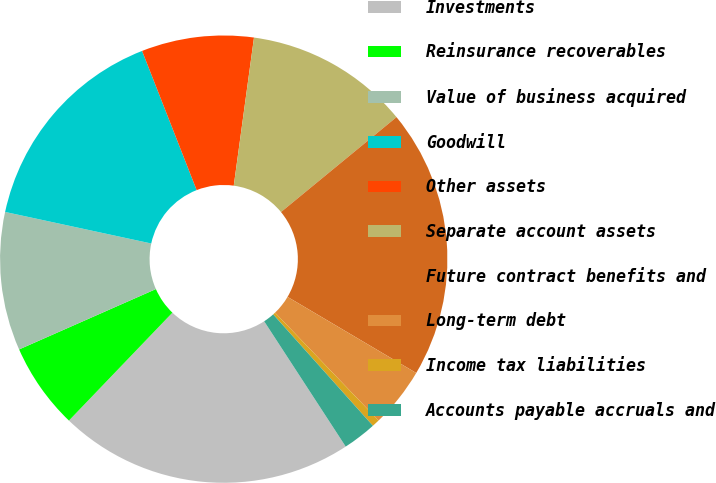<chart> <loc_0><loc_0><loc_500><loc_500><pie_chart><fcel>Investments<fcel>Reinsurance recoverables<fcel>Value of business acquired<fcel>Goodwill<fcel>Other assets<fcel>Separate account assets<fcel>Future contract benefits and<fcel>Long-term debt<fcel>Income tax liabilities<fcel>Accounts payable accruals and<nl><fcel>21.35%<fcel>6.22%<fcel>10.0%<fcel>15.67%<fcel>8.11%<fcel>11.89%<fcel>19.45%<fcel>4.33%<fcel>0.55%<fcel>2.44%<nl></chart> 